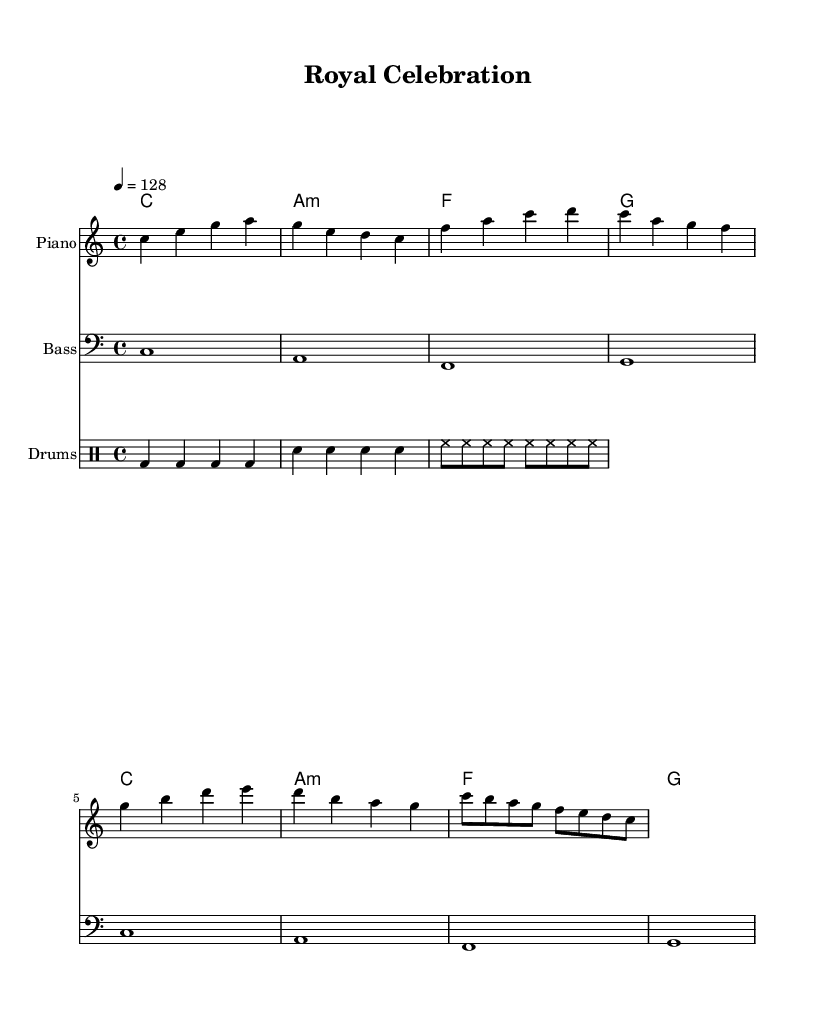What is the key signature of this music? The key signature is C major, which is indicated at the beginning of the staff and has no sharps or flats.
Answer: C major What is the time signature of this music? The time signature is 4/4, which is shown at the beginning of the staff and indicates 4 beats per measure.
Answer: 4/4 What is the tempo marking of this piece? The tempo marking is specified as 4 = 128, indicating a brisk pace of 128 beats per minute in common time.
Answer: 128 How many measures are in the melody section? The melody section has 8 measures, as counted from the notes and bar lines present in the melody staff.
Answer: 8 What is the first chord in the harmonies? The first chord in the harmonies is C major, as it is listed first in the chord sequence after the chord mode starts.
Answer: C What instruments are featured in this score? The score features piano, bass, and drums, as indicated by the instrument names above each staff.
Answer: Piano, Bass, Drums What type of dance genre does this music represent? This music represents an upbeat dance pop genre, as suggested by its lively tempo and celebratory layout, reflecting royal weddings and coronations.
Answer: Dance pop 